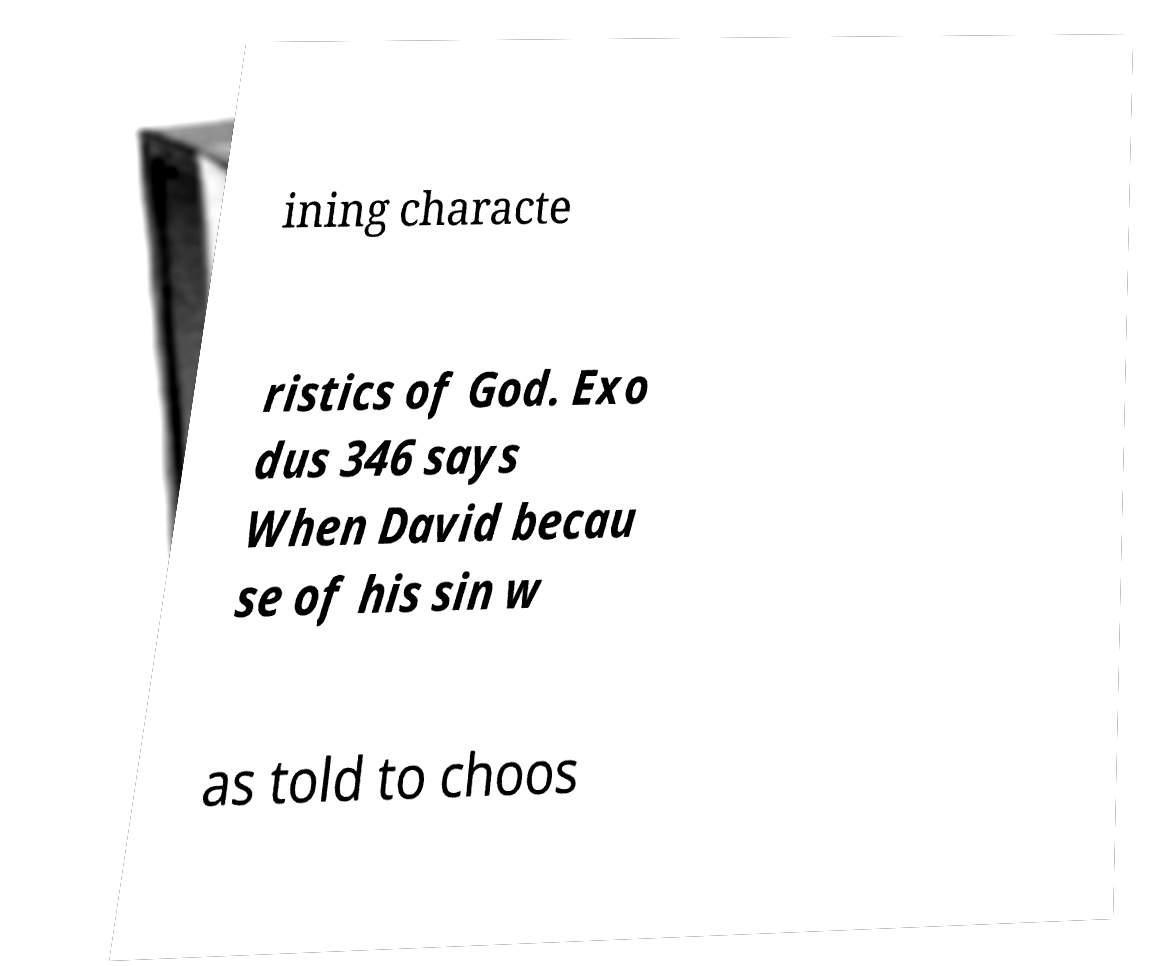There's text embedded in this image that I need extracted. Can you transcribe it verbatim? ining characte ristics of God. Exo dus 346 says When David becau se of his sin w as told to choos 